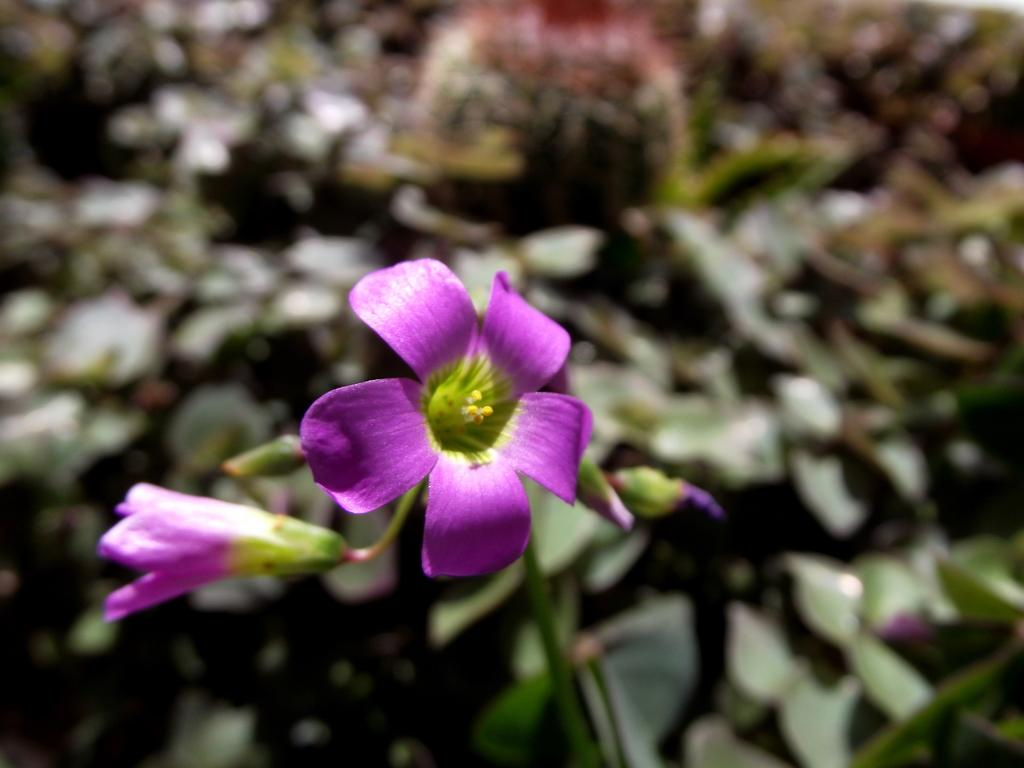What type of plant is visible in the image? There is a flower plant in the image. What color is the flower on the plant? The flower is purple in color. Can you describe the background of the image? The background of the image is blurred. What type of houses can be seen in the background of the image? There are no houses visible in the image; the background is blurred. What type of attack is being carried out by the flower in the image? The flower is not attacking anything in the image; it is simply a stationary plant. 